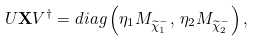<formula> <loc_0><loc_0><loc_500><loc_500>U { \mathbf X } V ^ { \dagger } = d i a g \left ( \eta _ { 1 } M _ { \widetilde { \chi } ^ { - } _ { 1 } } , \, \eta _ { 2 } M _ { \widetilde { \chi } ^ { - } _ { 2 } } \right ) ,</formula> 